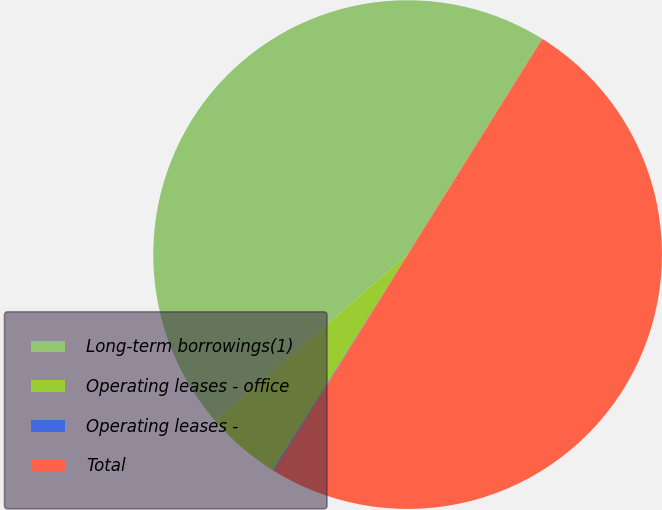Convert chart to OTSL. <chart><loc_0><loc_0><loc_500><loc_500><pie_chart><fcel>Long-term borrowings(1)<fcel>Operating leases - office<fcel>Operating leases -<fcel>Total<nl><fcel>45.24%<fcel>4.76%<fcel>0.07%<fcel>49.93%<nl></chart> 